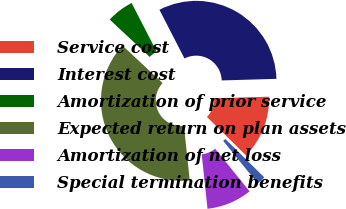<chart> <loc_0><loc_0><loc_500><loc_500><pie_chart><fcel>Service cost<fcel>Interest cost<fcel>Amortization of prior service<fcel>Expected return on plan assets<fcel>Amortization of net loss<fcel>Special termination benefits<nl><fcel>12.84%<fcel>32.1%<fcel>5.47%<fcel>38.64%<fcel>9.16%<fcel>1.78%<nl></chart> 